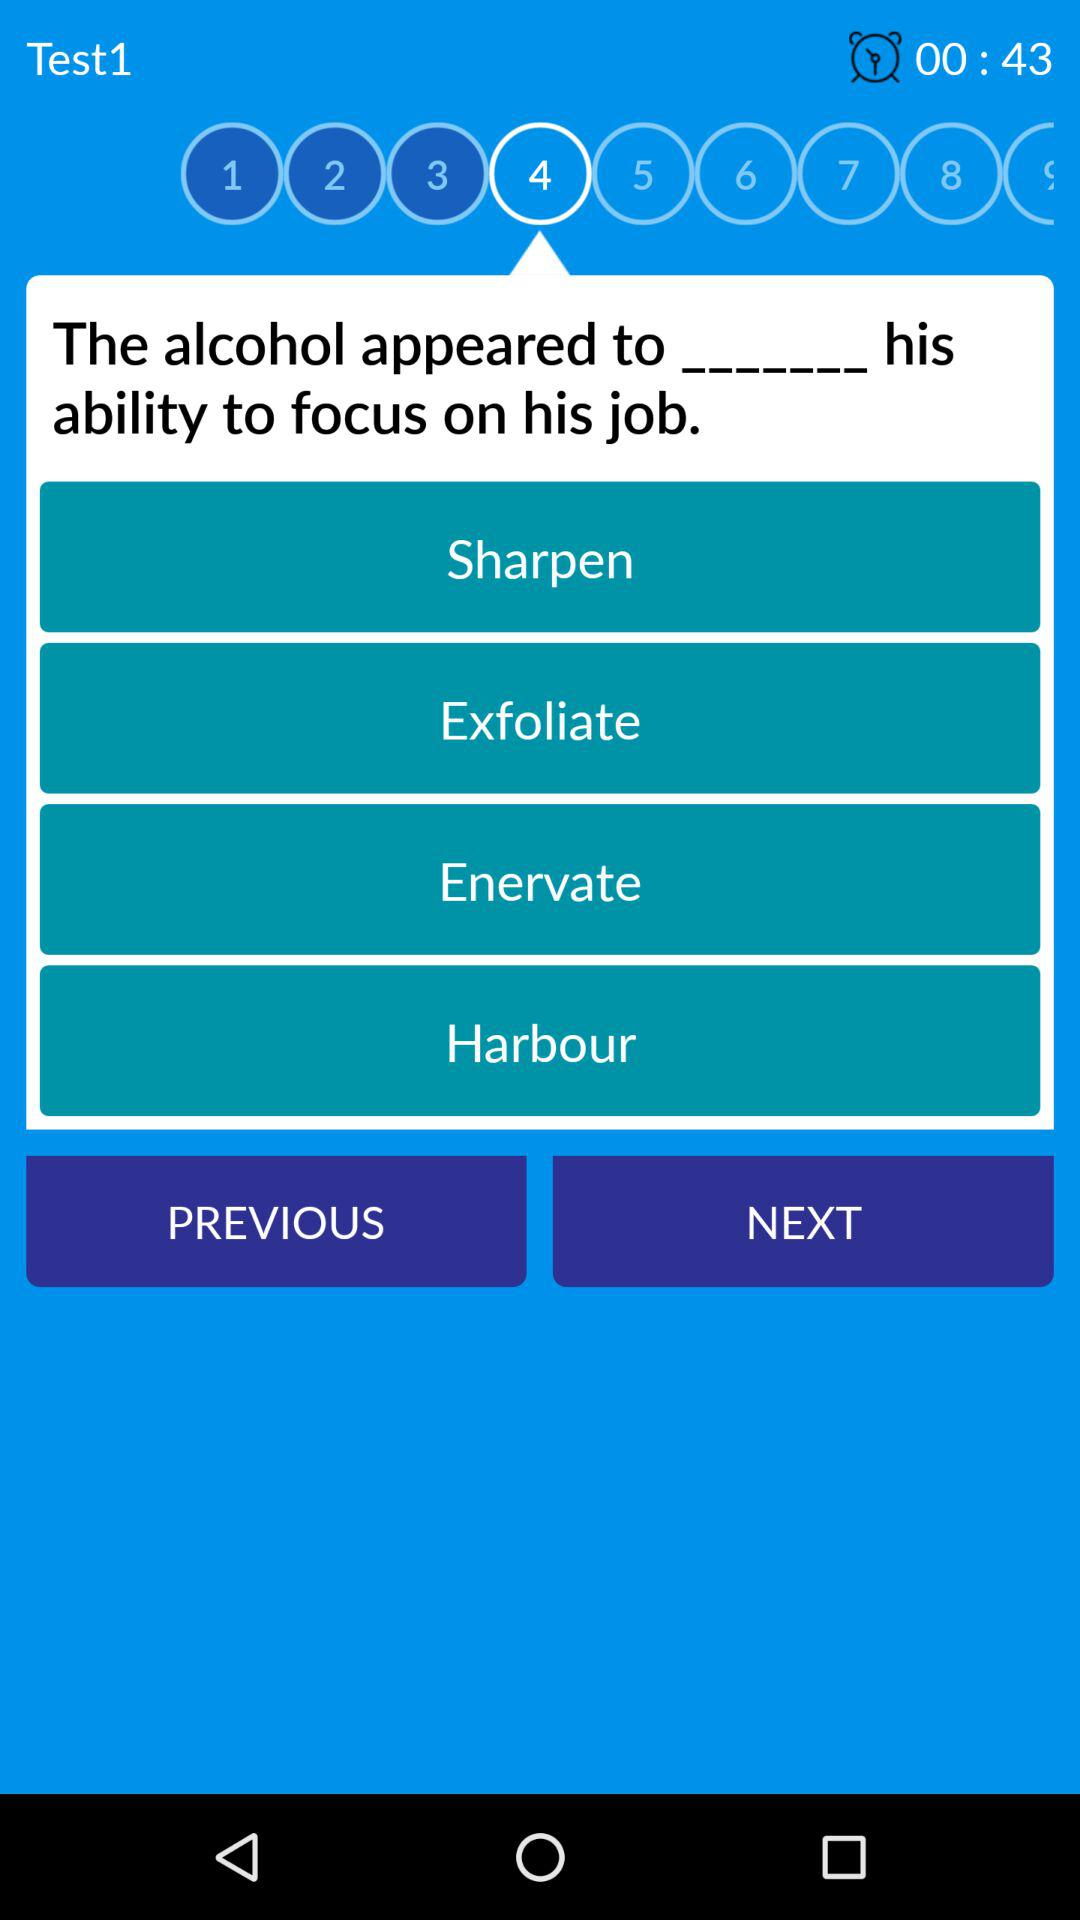At what question of test1 am I on? You are on question number 4. 